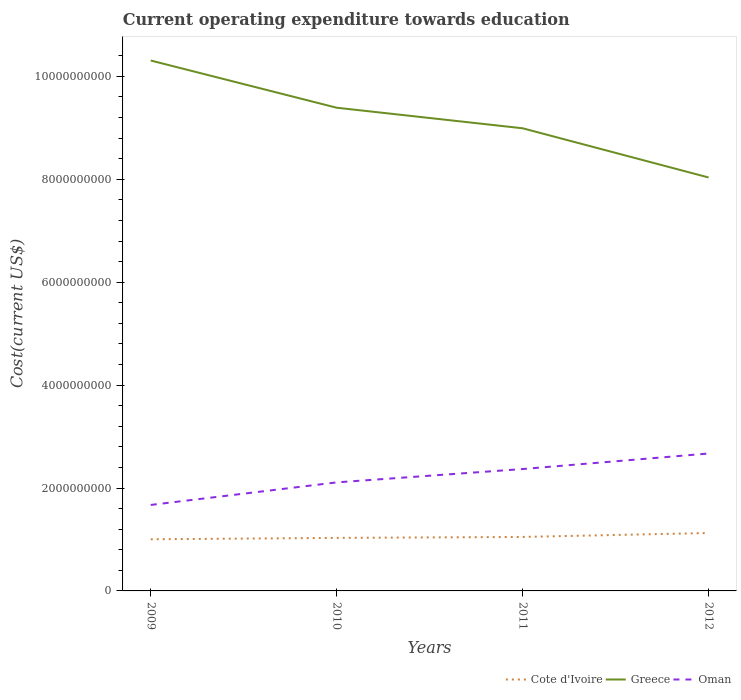Is the number of lines equal to the number of legend labels?
Your answer should be compact. Yes. Across all years, what is the maximum expenditure towards education in Cote d'Ivoire?
Your response must be concise. 1.00e+09. What is the total expenditure towards education in Cote d'Ivoire in the graph?
Offer a terse response. -4.52e+07. What is the difference between the highest and the second highest expenditure towards education in Cote d'Ivoire?
Your answer should be compact. 1.22e+08. What is the difference between the highest and the lowest expenditure towards education in Oman?
Keep it short and to the point. 2. What is the difference between two consecutive major ticks on the Y-axis?
Keep it short and to the point. 2.00e+09. Are the values on the major ticks of Y-axis written in scientific E-notation?
Make the answer very short. No. Does the graph contain any zero values?
Provide a short and direct response. No. Where does the legend appear in the graph?
Your answer should be very brief. Bottom right. How many legend labels are there?
Keep it short and to the point. 3. What is the title of the graph?
Give a very brief answer. Current operating expenditure towards education. Does "East Asia (developing only)" appear as one of the legend labels in the graph?
Your answer should be very brief. No. What is the label or title of the X-axis?
Your response must be concise. Years. What is the label or title of the Y-axis?
Ensure brevity in your answer.  Cost(current US$). What is the Cost(current US$) in Cote d'Ivoire in 2009?
Ensure brevity in your answer.  1.00e+09. What is the Cost(current US$) of Greece in 2009?
Offer a terse response. 1.03e+1. What is the Cost(current US$) in Oman in 2009?
Provide a short and direct response. 1.67e+09. What is the Cost(current US$) of Cote d'Ivoire in 2010?
Your answer should be very brief. 1.03e+09. What is the Cost(current US$) in Greece in 2010?
Offer a terse response. 9.39e+09. What is the Cost(current US$) of Oman in 2010?
Your answer should be compact. 2.11e+09. What is the Cost(current US$) of Cote d'Ivoire in 2011?
Give a very brief answer. 1.05e+09. What is the Cost(current US$) of Greece in 2011?
Keep it short and to the point. 8.99e+09. What is the Cost(current US$) in Oman in 2011?
Your response must be concise. 2.37e+09. What is the Cost(current US$) of Cote d'Ivoire in 2012?
Give a very brief answer. 1.13e+09. What is the Cost(current US$) in Greece in 2012?
Offer a very short reply. 8.04e+09. What is the Cost(current US$) of Oman in 2012?
Give a very brief answer. 2.67e+09. Across all years, what is the maximum Cost(current US$) of Cote d'Ivoire?
Your answer should be very brief. 1.13e+09. Across all years, what is the maximum Cost(current US$) in Greece?
Your response must be concise. 1.03e+1. Across all years, what is the maximum Cost(current US$) of Oman?
Offer a terse response. 2.67e+09. Across all years, what is the minimum Cost(current US$) of Cote d'Ivoire?
Offer a very short reply. 1.00e+09. Across all years, what is the minimum Cost(current US$) of Greece?
Your answer should be compact. 8.04e+09. Across all years, what is the minimum Cost(current US$) in Oman?
Give a very brief answer. 1.67e+09. What is the total Cost(current US$) in Cote d'Ivoire in the graph?
Provide a short and direct response. 4.21e+09. What is the total Cost(current US$) of Greece in the graph?
Make the answer very short. 3.67e+1. What is the total Cost(current US$) of Oman in the graph?
Make the answer very short. 8.82e+09. What is the difference between the Cost(current US$) of Cote d'Ivoire in 2009 and that in 2010?
Your answer should be compact. -2.71e+07. What is the difference between the Cost(current US$) in Greece in 2009 and that in 2010?
Offer a very short reply. 9.18e+08. What is the difference between the Cost(current US$) of Oman in 2009 and that in 2010?
Your answer should be very brief. -4.38e+08. What is the difference between the Cost(current US$) of Cote d'Ivoire in 2009 and that in 2011?
Give a very brief answer. -4.52e+07. What is the difference between the Cost(current US$) of Greece in 2009 and that in 2011?
Your response must be concise. 1.32e+09. What is the difference between the Cost(current US$) in Oman in 2009 and that in 2011?
Your answer should be very brief. -6.98e+08. What is the difference between the Cost(current US$) in Cote d'Ivoire in 2009 and that in 2012?
Make the answer very short. -1.22e+08. What is the difference between the Cost(current US$) of Greece in 2009 and that in 2012?
Offer a very short reply. 2.27e+09. What is the difference between the Cost(current US$) in Oman in 2009 and that in 2012?
Offer a very short reply. -1.00e+09. What is the difference between the Cost(current US$) of Cote d'Ivoire in 2010 and that in 2011?
Provide a short and direct response. -1.81e+07. What is the difference between the Cost(current US$) of Greece in 2010 and that in 2011?
Make the answer very short. 3.99e+08. What is the difference between the Cost(current US$) in Oman in 2010 and that in 2011?
Your answer should be compact. -2.60e+08. What is the difference between the Cost(current US$) of Cote d'Ivoire in 2010 and that in 2012?
Your answer should be compact. -9.49e+07. What is the difference between the Cost(current US$) in Greece in 2010 and that in 2012?
Your answer should be very brief. 1.36e+09. What is the difference between the Cost(current US$) of Oman in 2010 and that in 2012?
Offer a very short reply. -5.61e+08. What is the difference between the Cost(current US$) in Cote d'Ivoire in 2011 and that in 2012?
Make the answer very short. -7.67e+07. What is the difference between the Cost(current US$) of Greece in 2011 and that in 2012?
Provide a succinct answer. 9.56e+08. What is the difference between the Cost(current US$) of Oman in 2011 and that in 2012?
Keep it short and to the point. -3.02e+08. What is the difference between the Cost(current US$) of Cote d'Ivoire in 2009 and the Cost(current US$) of Greece in 2010?
Keep it short and to the point. -8.39e+09. What is the difference between the Cost(current US$) of Cote d'Ivoire in 2009 and the Cost(current US$) of Oman in 2010?
Your answer should be compact. -1.11e+09. What is the difference between the Cost(current US$) of Greece in 2009 and the Cost(current US$) of Oman in 2010?
Provide a short and direct response. 8.20e+09. What is the difference between the Cost(current US$) of Cote d'Ivoire in 2009 and the Cost(current US$) of Greece in 2011?
Make the answer very short. -7.99e+09. What is the difference between the Cost(current US$) in Cote d'Ivoire in 2009 and the Cost(current US$) in Oman in 2011?
Give a very brief answer. -1.37e+09. What is the difference between the Cost(current US$) in Greece in 2009 and the Cost(current US$) in Oman in 2011?
Provide a short and direct response. 7.94e+09. What is the difference between the Cost(current US$) in Cote d'Ivoire in 2009 and the Cost(current US$) in Greece in 2012?
Offer a terse response. -7.03e+09. What is the difference between the Cost(current US$) in Cote d'Ivoire in 2009 and the Cost(current US$) in Oman in 2012?
Your answer should be very brief. -1.67e+09. What is the difference between the Cost(current US$) in Greece in 2009 and the Cost(current US$) in Oman in 2012?
Make the answer very short. 7.64e+09. What is the difference between the Cost(current US$) in Cote d'Ivoire in 2010 and the Cost(current US$) in Greece in 2011?
Keep it short and to the point. -7.96e+09. What is the difference between the Cost(current US$) of Cote d'Ivoire in 2010 and the Cost(current US$) of Oman in 2011?
Offer a very short reply. -1.34e+09. What is the difference between the Cost(current US$) of Greece in 2010 and the Cost(current US$) of Oman in 2011?
Your response must be concise. 7.02e+09. What is the difference between the Cost(current US$) of Cote d'Ivoire in 2010 and the Cost(current US$) of Greece in 2012?
Your response must be concise. -7.00e+09. What is the difference between the Cost(current US$) of Cote d'Ivoire in 2010 and the Cost(current US$) of Oman in 2012?
Make the answer very short. -1.64e+09. What is the difference between the Cost(current US$) of Greece in 2010 and the Cost(current US$) of Oman in 2012?
Provide a succinct answer. 6.72e+09. What is the difference between the Cost(current US$) in Cote d'Ivoire in 2011 and the Cost(current US$) in Greece in 2012?
Ensure brevity in your answer.  -6.99e+09. What is the difference between the Cost(current US$) in Cote d'Ivoire in 2011 and the Cost(current US$) in Oman in 2012?
Your answer should be very brief. -1.62e+09. What is the difference between the Cost(current US$) of Greece in 2011 and the Cost(current US$) of Oman in 2012?
Provide a short and direct response. 6.32e+09. What is the average Cost(current US$) in Cote d'Ivoire per year?
Provide a succinct answer. 1.05e+09. What is the average Cost(current US$) in Greece per year?
Your response must be concise. 9.18e+09. What is the average Cost(current US$) of Oman per year?
Provide a short and direct response. 2.21e+09. In the year 2009, what is the difference between the Cost(current US$) in Cote d'Ivoire and Cost(current US$) in Greece?
Keep it short and to the point. -9.30e+09. In the year 2009, what is the difference between the Cost(current US$) of Cote d'Ivoire and Cost(current US$) of Oman?
Your answer should be compact. -6.67e+08. In the year 2009, what is the difference between the Cost(current US$) of Greece and Cost(current US$) of Oman?
Make the answer very short. 8.64e+09. In the year 2010, what is the difference between the Cost(current US$) in Cote d'Ivoire and Cost(current US$) in Greece?
Offer a very short reply. -8.36e+09. In the year 2010, what is the difference between the Cost(current US$) of Cote d'Ivoire and Cost(current US$) of Oman?
Ensure brevity in your answer.  -1.08e+09. In the year 2010, what is the difference between the Cost(current US$) in Greece and Cost(current US$) in Oman?
Give a very brief answer. 7.28e+09. In the year 2011, what is the difference between the Cost(current US$) of Cote d'Ivoire and Cost(current US$) of Greece?
Keep it short and to the point. -7.94e+09. In the year 2011, what is the difference between the Cost(current US$) in Cote d'Ivoire and Cost(current US$) in Oman?
Your response must be concise. -1.32e+09. In the year 2011, what is the difference between the Cost(current US$) in Greece and Cost(current US$) in Oman?
Provide a succinct answer. 6.62e+09. In the year 2012, what is the difference between the Cost(current US$) in Cote d'Ivoire and Cost(current US$) in Greece?
Make the answer very short. -6.91e+09. In the year 2012, what is the difference between the Cost(current US$) of Cote d'Ivoire and Cost(current US$) of Oman?
Make the answer very short. -1.55e+09. In the year 2012, what is the difference between the Cost(current US$) in Greece and Cost(current US$) in Oman?
Your response must be concise. 5.36e+09. What is the ratio of the Cost(current US$) of Cote d'Ivoire in 2009 to that in 2010?
Make the answer very short. 0.97. What is the ratio of the Cost(current US$) of Greece in 2009 to that in 2010?
Make the answer very short. 1.1. What is the ratio of the Cost(current US$) in Oman in 2009 to that in 2010?
Ensure brevity in your answer.  0.79. What is the ratio of the Cost(current US$) of Cote d'Ivoire in 2009 to that in 2011?
Ensure brevity in your answer.  0.96. What is the ratio of the Cost(current US$) in Greece in 2009 to that in 2011?
Ensure brevity in your answer.  1.15. What is the ratio of the Cost(current US$) of Oman in 2009 to that in 2011?
Ensure brevity in your answer.  0.71. What is the ratio of the Cost(current US$) in Cote d'Ivoire in 2009 to that in 2012?
Provide a short and direct response. 0.89. What is the ratio of the Cost(current US$) of Greece in 2009 to that in 2012?
Your answer should be compact. 1.28. What is the ratio of the Cost(current US$) in Oman in 2009 to that in 2012?
Offer a terse response. 0.63. What is the ratio of the Cost(current US$) of Cote d'Ivoire in 2010 to that in 2011?
Ensure brevity in your answer.  0.98. What is the ratio of the Cost(current US$) of Greece in 2010 to that in 2011?
Ensure brevity in your answer.  1.04. What is the ratio of the Cost(current US$) of Oman in 2010 to that in 2011?
Make the answer very short. 0.89. What is the ratio of the Cost(current US$) of Cote d'Ivoire in 2010 to that in 2012?
Ensure brevity in your answer.  0.92. What is the ratio of the Cost(current US$) of Greece in 2010 to that in 2012?
Provide a short and direct response. 1.17. What is the ratio of the Cost(current US$) in Oman in 2010 to that in 2012?
Your answer should be compact. 0.79. What is the ratio of the Cost(current US$) in Cote d'Ivoire in 2011 to that in 2012?
Give a very brief answer. 0.93. What is the ratio of the Cost(current US$) in Greece in 2011 to that in 2012?
Make the answer very short. 1.12. What is the ratio of the Cost(current US$) of Oman in 2011 to that in 2012?
Provide a short and direct response. 0.89. What is the difference between the highest and the second highest Cost(current US$) in Cote d'Ivoire?
Provide a short and direct response. 7.67e+07. What is the difference between the highest and the second highest Cost(current US$) in Greece?
Offer a very short reply. 9.18e+08. What is the difference between the highest and the second highest Cost(current US$) of Oman?
Make the answer very short. 3.02e+08. What is the difference between the highest and the lowest Cost(current US$) of Cote d'Ivoire?
Offer a very short reply. 1.22e+08. What is the difference between the highest and the lowest Cost(current US$) in Greece?
Your answer should be compact. 2.27e+09. What is the difference between the highest and the lowest Cost(current US$) in Oman?
Give a very brief answer. 1.00e+09. 